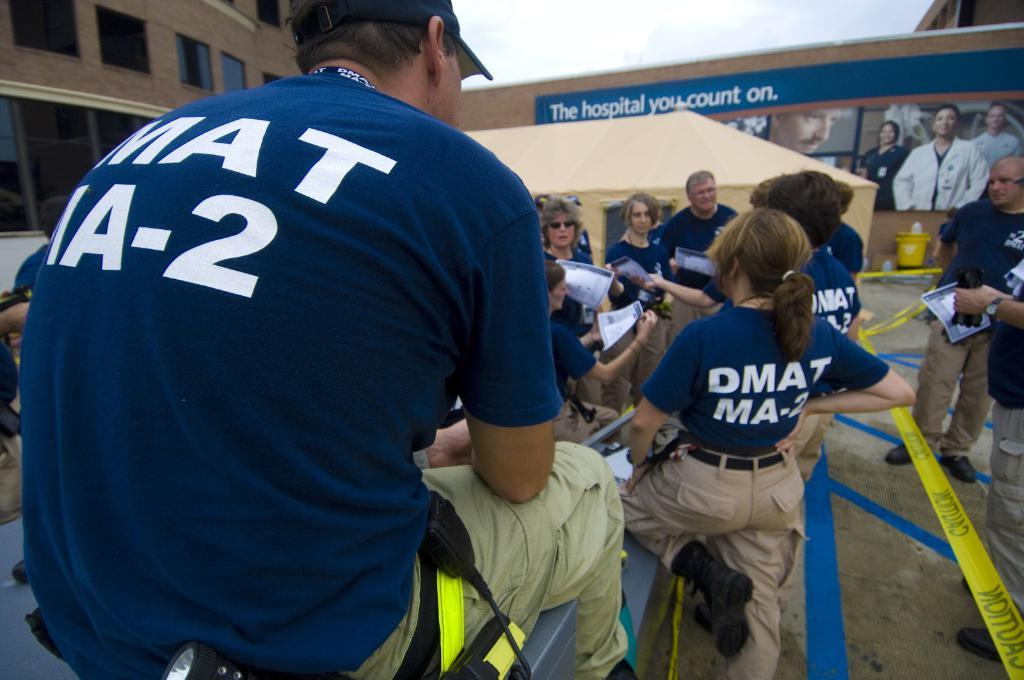<image>
Present a compact description of the photo's key features. several people gathered around wearing blue shirts with DMAT MA-2 on the back and building in the background has sign the hospital you can count on 